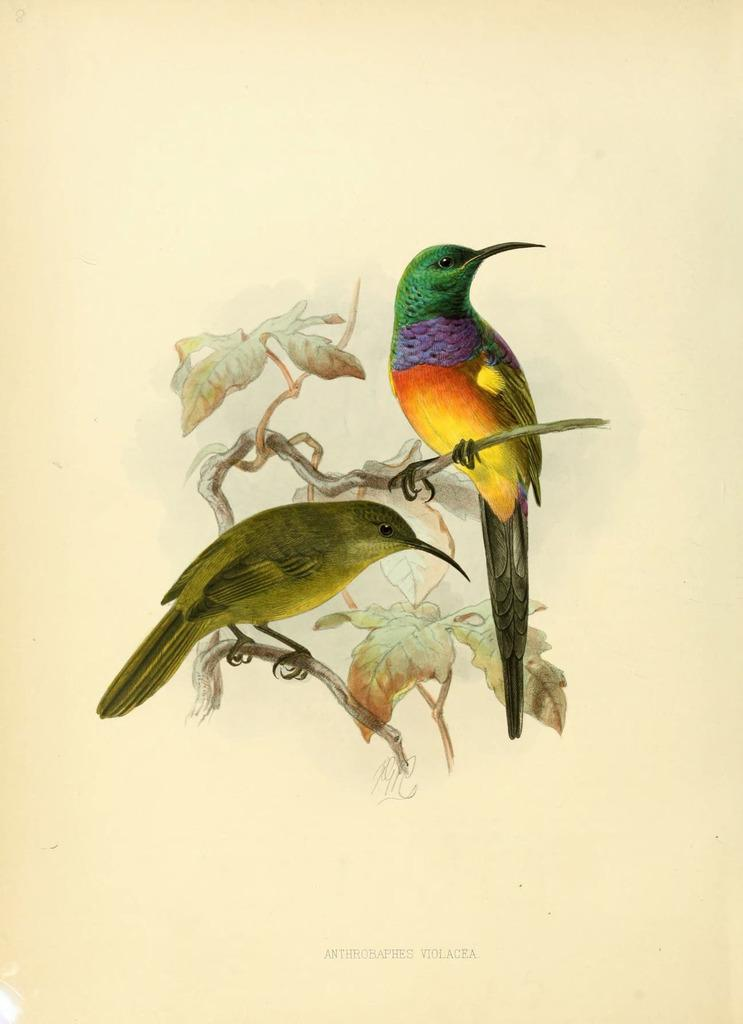What is depicted in the image? There is a drawing in the image. What animals are featured in the drawing? The drawing contains two birds. Where are the birds located in the drawing? The birds are standing on a branch. What is the branch like in the drawing? The branch has leaves. What additional information is provided at the bottom of the drawing? There is text at the bottom of the drawing. What type of trouble is the bird on the left experiencing in the image? There is no indication of trouble in the image; the birds are simply standing on a branch. 